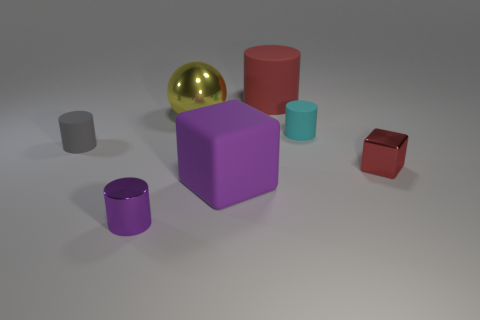Which object in the image is reflective? The object that appears to be reflective is the golden sphere. 